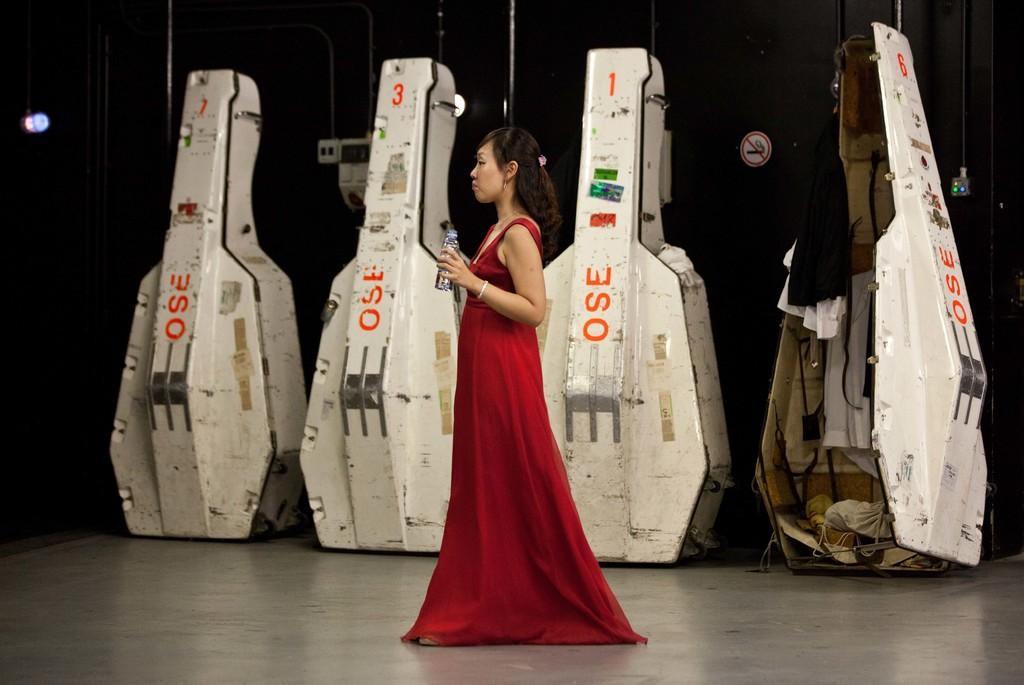How would you summarize this image in a sentence or two? This picture shows a few boxes on the dais and we see a woman standing and holding a bottle in the hand and we see a caution board. 